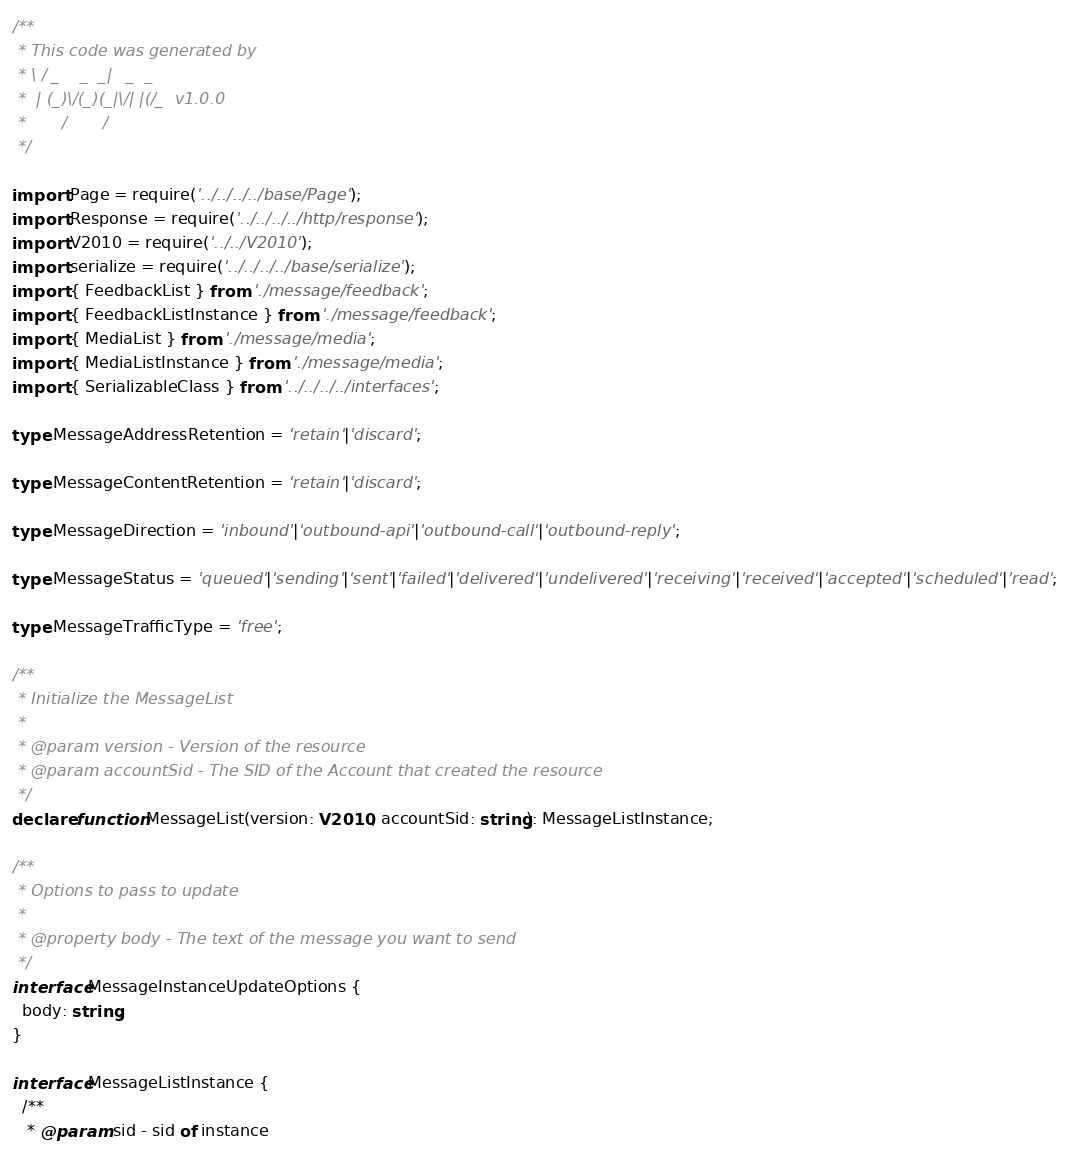Convert code to text. <code><loc_0><loc_0><loc_500><loc_500><_TypeScript_>/**
 * This code was generated by
 * \ / _    _  _|   _  _
 *  | (_)\/(_)(_|\/| |(/_  v1.0.0
 *       /       /
 */

import Page = require('../../../../base/Page');
import Response = require('../../../../http/response');
import V2010 = require('../../V2010');
import serialize = require('../../../../base/serialize');
import { FeedbackList } from './message/feedback';
import { FeedbackListInstance } from './message/feedback';
import { MediaList } from './message/media';
import { MediaListInstance } from './message/media';
import { SerializableClass } from '../../../../interfaces';

type MessageAddressRetention = 'retain'|'discard';

type MessageContentRetention = 'retain'|'discard';

type MessageDirection = 'inbound'|'outbound-api'|'outbound-call'|'outbound-reply';

type MessageStatus = 'queued'|'sending'|'sent'|'failed'|'delivered'|'undelivered'|'receiving'|'received'|'accepted'|'scheduled'|'read';

type MessageTrafficType = 'free';

/**
 * Initialize the MessageList
 *
 * @param version - Version of the resource
 * @param accountSid - The SID of the Account that created the resource
 */
declare function MessageList(version: V2010, accountSid: string): MessageListInstance;

/**
 * Options to pass to update
 *
 * @property body - The text of the message you want to send
 */
interface MessageInstanceUpdateOptions {
  body: string;
}

interface MessageListInstance {
  /**
   * @param sid - sid of instance</code> 